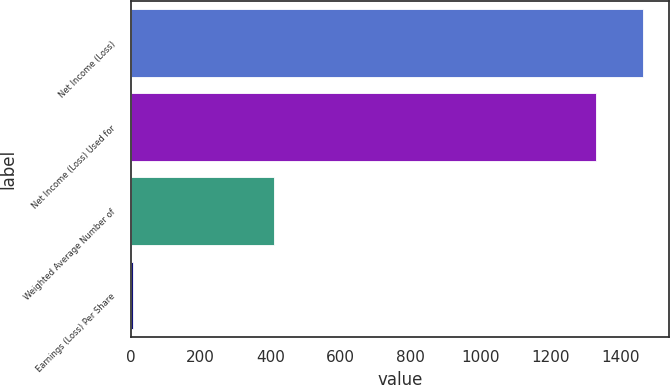<chart> <loc_0><loc_0><loc_500><loc_500><bar_chart><fcel>Net Income (Loss)<fcel>Net Income (Loss) Used for<fcel>Weighted Average Number of<fcel>Earnings (Loss) Per Share<nl><fcel>1464.24<fcel>1330<fcel>410.3<fcel>7.58<nl></chart> 